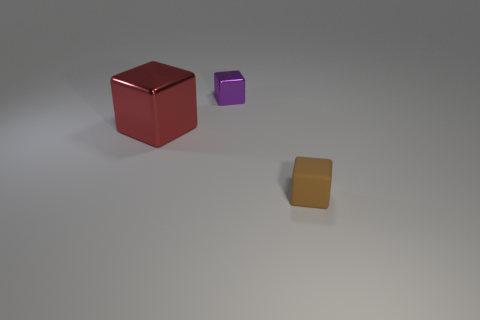What is the material of the cube on the right side of the cube behind the red shiny block?
Your answer should be compact. Rubber. What is the size of the object that is in front of the small purple shiny object and on the left side of the tiny brown matte object?
Make the answer very short. Large. How many rubber objects are either brown things or large red cubes?
Give a very brief answer. 1. What size is the thing right of the purple cube?
Give a very brief answer. Small. There is a thing that is made of the same material as the large block; what size is it?
Your answer should be compact. Small. Are any yellow blocks visible?
Provide a short and direct response. No. There is a small cube that is behind the object that is on the right side of the tiny cube on the left side of the tiny brown thing; what color is it?
Provide a succinct answer. Purple. There is a small brown block; are there any large red metallic blocks to the left of it?
Your answer should be very brief. Yes. Are there any other objects that have the same material as the big object?
Your response must be concise. Yes. What is the color of the rubber thing?
Offer a terse response. Brown. 